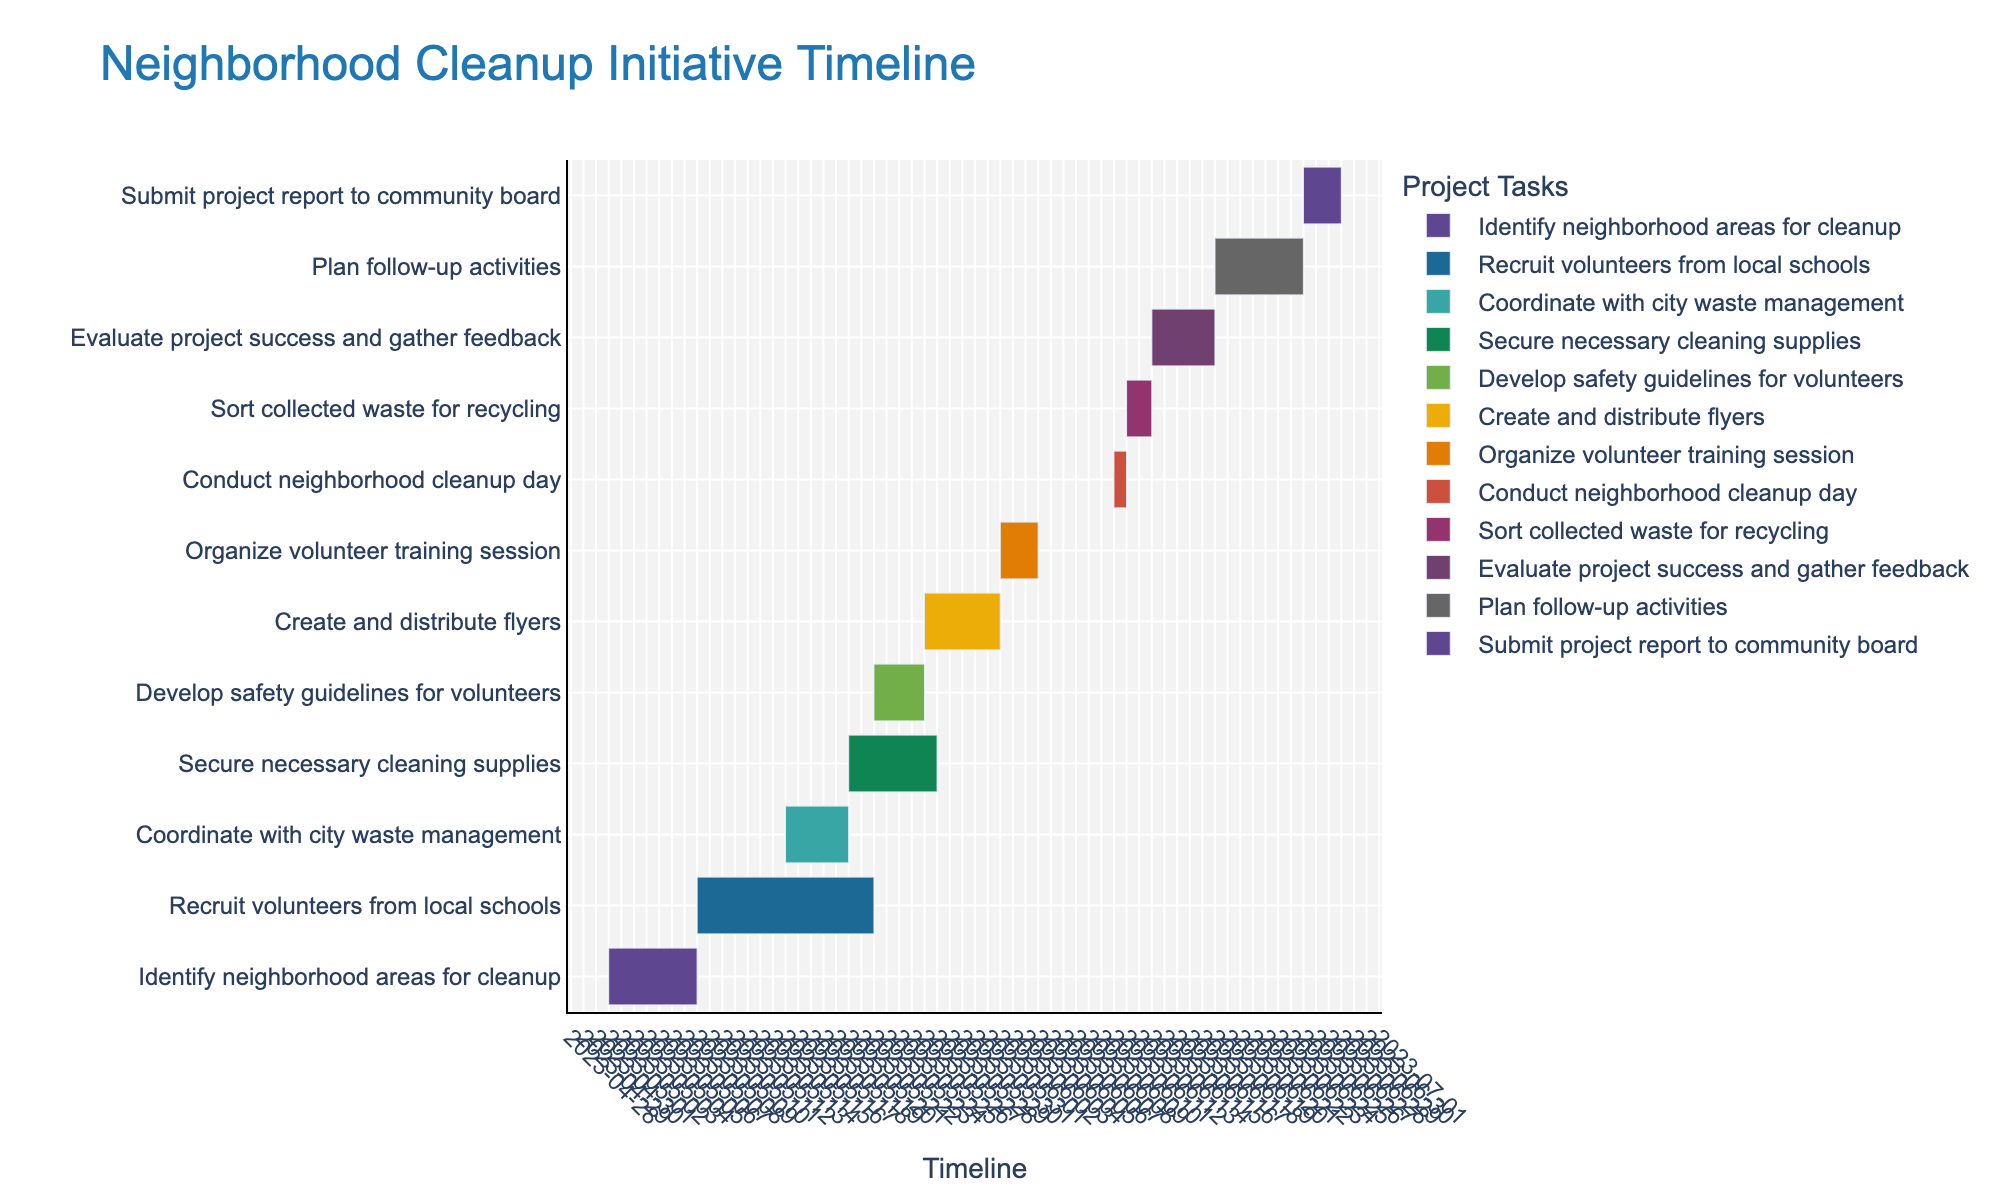Which task starts on June 10th, 2023? Find the task scheduled to start on June 10th on the timeline. The task is "Conduct neighborhood cleanup day."
Answer: Conduct neighborhood cleanup day How long does it take to secure necessary cleaning supplies? Refer to the duration of the task "Secure necessary cleaning supplies" on the timeline, which states it lasts for 7 days.
Answer: 7 days Which task ends the latest? Look for the task with the latest end date on the timeline. The task "Submit project report to community board" ends last, on June 28th, 2023.
Answer: Submit project report to community board What is the total duration of the entire project from the start date of the first task to the end date of the last task? The first task, "Identify neighborhood areas for cleanup," starts on May 1st, 2023, and the last task, "Submit project report to community board," ends on June 28th, 2023. Calculate the difference between these dates.
Answer: 58 days Which tasks overlap in the second week of June 2023? Identify all tasks that have start and end dates overlapping in the second week of June 2023 (June 8th - June 14th). "Organize volunteer training session", "Conduct neighborhood cleanup day", "Sort collected waste for recycling", and "Evaluate project success and gather feedback" overlap in this period.
Answer: Organize volunteer training session, Conduct neighborhood cleanup day, Sort collected waste for recycling, Evaluate project success and gather feedback How many days are there between the end of "Coordinate with city waste management" and the start of "Secure necessary cleaning supplies"? The task "Coordinate with city waste management" ends on May 20th, 2023, and "Secure necessary cleaning supplies" starts on the same day. Calculate the difference; there are 0 days between these tasks.
Answer: 0 days Which task has the shortest duration? Reference the timeline to find the task with the shortest duration. "Conduct neighborhood cleanup day" lasts only for 1 day.
Answer: Conduct neighborhood cleanup day What is the duration difference between "Recruit volunteers from local schools" and "Evaluate project success and gather feedback"? "Recruit volunteers from local schools" lasts for 14 days, and "Evaluate project success and gather feedback" lasts for 5 days. The difference in duration is 14 - 5 = 9 days.
Answer: 9 days Which two tasks overlap in terms of their end and start dates? By examining the timeline, you can see that "Coordinate with city waste management" ends on May 15th, 2023, and "Secure necessary cleaning supplies" starts the same day. Thus, these two tasks overlap.
Answer: Coordinate with city waste management and Secure necessary cleaning supplies 